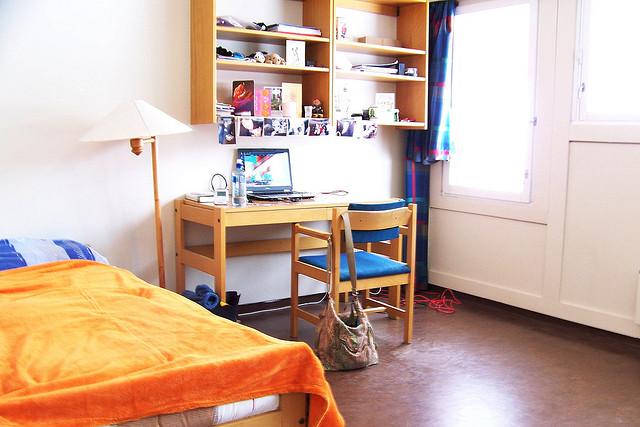Where is the laptop?
Keep it brief. On desk. Where is the purse at?
Concise answer only. On chair. Are there several fruits that are the color of the bedspread?
Keep it brief. Yes. 